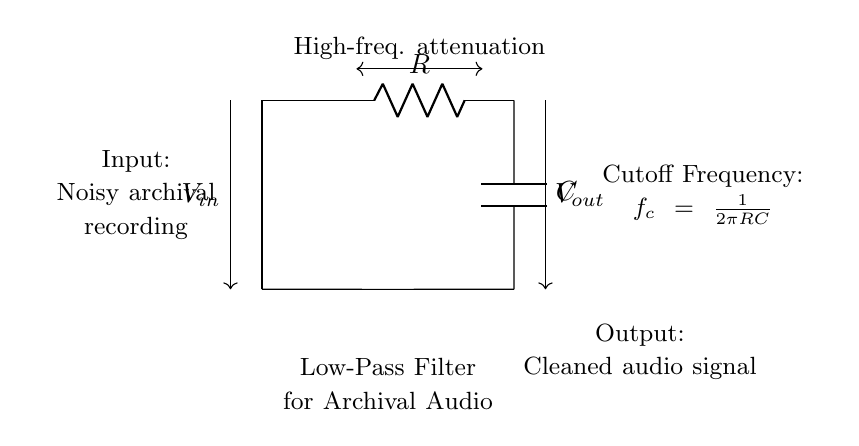What type of filter does this circuit represent? This circuit is designated as a low-pass filter. The schematic indicates that it allows low-frequency signals to pass while attenuating higher frequency signals.
Answer: Low-pass filter What components are used in this low-pass filter circuit? The circuit includes a resistor and a capacitor, shown with `R` representing the resistor and `C` representing the capacitor. Together, these components create the filter effect.
Answer: Resistor and capacitor What is the function of the input voltage in this circuit? The input voltage represents the noisy archival recording that needs processing. It is connected to the circuit to be filtered, with the expectation that noise will be reduced in the output.
Answer: Noisy archival recording What happens to high-frequency signals in this circuit? High-frequency signals are attenuated or reduced as they pass through the filter. The circuit is designed specifically to limit high-frequency content while allowing low frequencies to pass through unaffected.
Answer: Attenuated What is the cutoff frequency formula provided in the circuit? The cutoff frequency is indicated by the formula `f_c = 1/(2πRC)`. This formula calculates the frequency at which the output power is reduced to half of the input power.
Answer: f_c = 1/(2πRC) What does the output voltage represent? The output voltage signifies the cleaned audio signal after the noise reduction process has been applied to the input signal. This is the final output that will be used for further analysis or playback.
Answer: Cleaned audio signal 